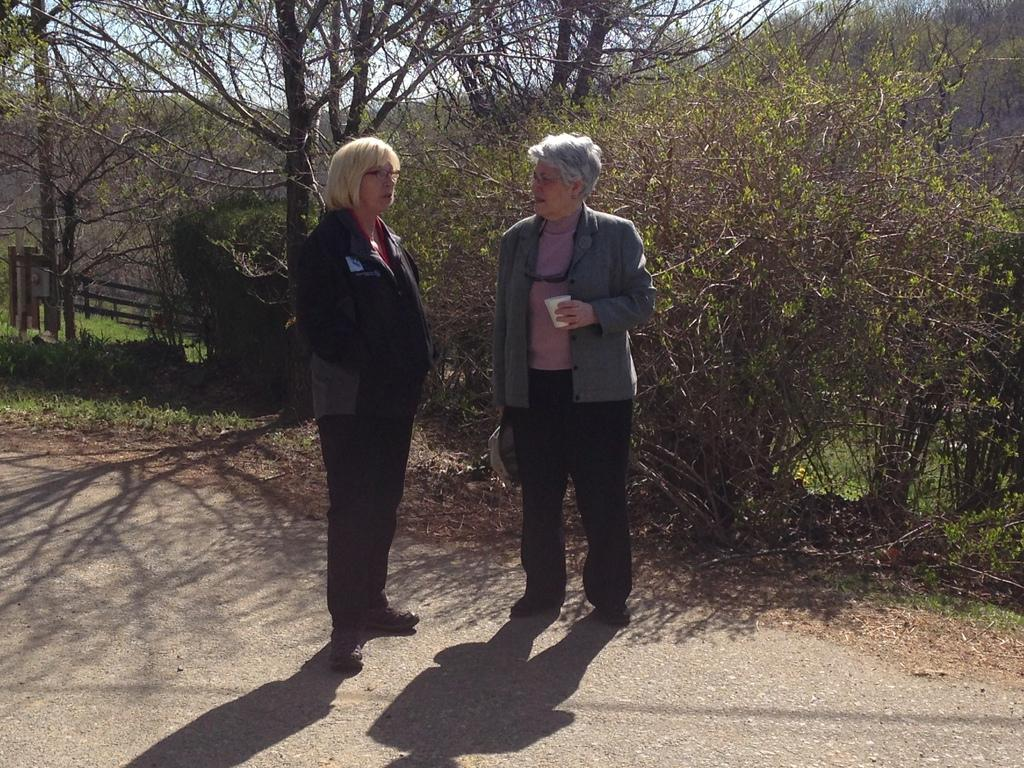How many people are present in the image? There are two people standing in the image. What can be seen in the background of the image? Trees are visible in the image. What month is it in the image? The month cannot be determined from the image, as there is no information about the time of year. How many kittens are present in the image? There are no kittens present in the image. 